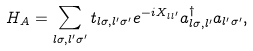Convert formula to latex. <formula><loc_0><loc_0><loc_500><loc_500>H _ { A } = \sum _ { l \sigma , l ^ { \prime } \sigma ^ { \prime } } t _ { l \sigma , l ^ { \prime } \sigma ^ { \prime } } e ^ { - i X _ { l l ^ { \prime } } } a ^ { \dagger } _ { l \sigma , l ^ { \prime } } a _ { l ^ { \prime } \sigma ^ { \prime } } ,</formula> 